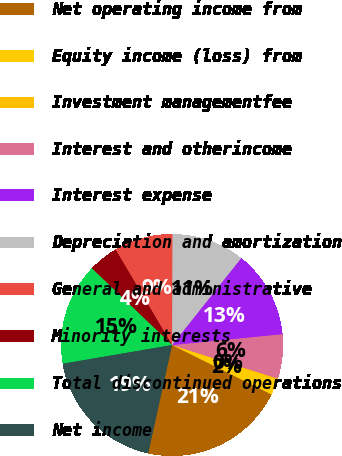Convert chart to OTSL. <chart><loc_0><loc_0><loc_500><loc_500><pie_chart><fcel>Net operating income from<fcel>Equity income (loss) from<fcel>Investment managementfee<fcel>Interest and otherincome<fcel>Interest expense<fcel>Depreciation and amortization<fcel>General and administrative<fcel>Minority interests<fcel>Total discontinued operations<fcel>Net income<nl><fcel>21.12%<fcel>2.27%<fcel>0.18%<fcel>6.46%<fcel>12.74%<fcel>10.65%<fcel>8.55%<fcel>4.36%<fcel>14.83%<fcel>18.85%<nl></chart> 